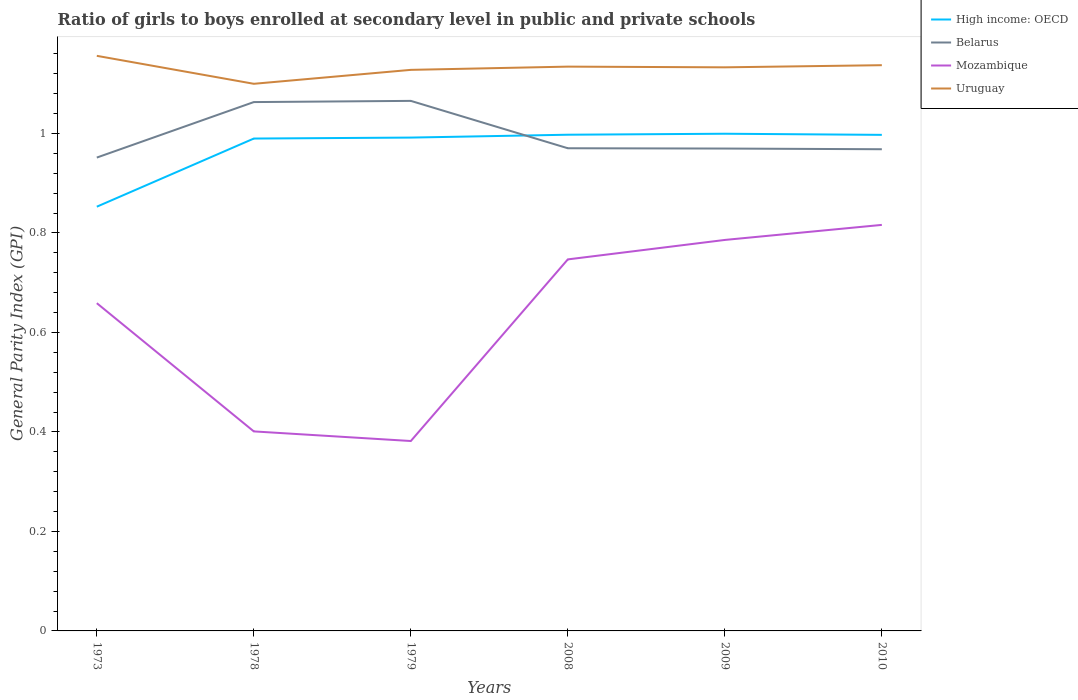Does the line corresponding to Mozambique intersect with the line corresponding to High income: OECD?
Your response must be concise. No. Is the number of lines equal to the number of legend labels?
Keep it short and to the point. Yes. Across all years, what is the maximum general parity index in Uruguay?
Ensure brevity in your answer.  1.1. What is the total general parity index in High income: OECD in the graph?
Your answer should be very brief. -0.01. What is the difference between the highest and the second highest general parity index in Belarus?
Provide a succinct answer. 0.11. What is the difference between the highest and the lowest general parity index in High income: OECD?
Make the answer very short. 5. Does the graph contain any zero values?
Provide a short and direct response. No. Where does the legend appear in the graph?
Keep it short and to the point. Top right. How many legend labels are there?
Your answer should be very brief. 4. What is the title of the graph?
Provide a succinct answer. Ratio of girls to boys enrolled at secondary level in public and private schools. What is the label or title of the Y-axis?
Provide a short and direct response. General Parity Index (GPI). What is the General Parity Index (GPI) of High income: OECD in 1973?
Give a very brief answer. 0.85. What is the General Parity Index (GPI) in Belarus in 1973?
Provide a succinct answer. 0.95. What is the General Parity Index (GPI) of Mozambique in 1973?
Offer a terse response. 0.66. What is the General Parity Index (GPI) in Uruguay in 1973?
Give a very brief answer. 1.16. What is the General Parity Index (GPI) in High income: OECD in 1978?
Provide a short and direct response. 0.99. What is the General Parity Index (GPI) in Belarus in 1978?
Give a very brief answer. 1.06. What is the General Parity Index (GPI) in Mozambique in 1978?
Offer a terse response. 0.4. What is the General Parity Index (GPI) in Uruguay in 1978?
Your answer should be compact. 1.1. What is the General Parity Index (GPI) of High income: OECD in 1979?
Give a very brief answer. 0.99. What is the General Parity Index (GPI) in Belarus in 1979?
Make the answer very short. 1.07. What is the General Parity Index (GPI) of Mozambique in 1979?
Your answer should be compact. 0.38. What is the General Parity Index (GPI) in Uruguay in 1979?
Your response must be concise. 1.13. What is the General Parity Index (GPI) of High income: OECD in 2008?
Your answer should be compact. 1. What is the General Parity Index (GPI) in Belarus in 2008?
Ensure brevity in your answer.  0.97. What is the General Parity Index (GPI) of Mozambique in 2008?
Keep it short and to the point. 0.75. What is the General Parity Index (GPI) of Uruguay in 2008?
Ensure brevity in your answer.  1.13. What is the General Parity Index (GPI) of High income: OECD in 2009?
Offer a very short reply. 1. What is the General Parity Index (GPI) in Belarus in 2009?
Provide a succinct answer. 0.97. What is the General Parity Index (GPI) of Mozambique in 2009?
Your answer should be compact. 0.79. What is the General Parity Index (GPI) of Uruguay in 2009?
Offer a terse response. 1.13. What is the General Parity Index (GPI) of High income: OECD in 2010?
Make the answer very short. 1. What is the General Parity Index (GPI) in Belarus in 2010?
Offer a very short reply. 0.97. What is the General Parity Index (GPI) in Mozambique in 2010?
Provide a succinct answer. 0.82. What is the General Parity Index (GPI) of Uruguay in 2010?
Ensure brevity in your answer.  1.14. Across all years, what is the maximum General Parity Index (GPI) of High income: OECD?
Provide a succinct answer. 1. Across all years, what is the maximum General Parity Index (GPI) of Belarus?
Ensure brevity in your answer.  1.07. Across all years, what is the maximum General Parity Index (GPI) in Mozambique?
Offer a very short reply. 0.82. Across all years, what is the maximum General Parity Index (GPI) in Uruguay?
Offer a terse response. 1.16. Across all years, what is the minimum General Parity Index (GPI) in High income: OECD?
Give a very brief answer. 0.85. Across all years, what is the minimum General Parity Index (GPI) of Belarus?
Provide a succinct answer. 0.95. Across all years, what is the minimum General Parity Index (GPI) of Mozambique?
Your answer should be compact. 0.38. Across all years, what is the minimum General Parity Index (GPI) in Uruguay?
Ensure brevity in your answer.  1.1. What is the total General Parity Index (GPI) in High income: OECD in the graph?
Offer a very short reply. 5.83. What is the total General Parity Index (GPI) in Belarus in the graph?
Provide a short and direct response. 5.99. What is the total General Parity Index (GPI) in Mozambique in the graph?
Your answer should be very brief. 3.79. What is the total General Parity Index (GPI) of Uruguay in the graph?
Offer a terse response. 6.79. What is the difference between the General Parity Index (GPI) of High income: OECD in 1973 and that in 1978?
Provide a succinct answer. -0.14. What is the difference between the General Parity Index (GPI) in Belarus in 1973 and that in 1978?
Your answer should be compact. -0.11. What is the difference between the General Parity Index (GPI) in Mozambique in 1973 and that in 1978?
Give a very brief answer. 0.26. What is the difference between the General Parity Index (GPI) of Uruguay in 1973 and that in 1978?
Provide a succinct answer. 0.06. What is the difference between the General Parity Index (GPI) in High income: OECD in 1973 and that in 1979?
Your answer should be compact. -0.14. What is the difference between the General Parity Index (GPI) of Belarus in 1973 and that in 1979?
Your response must be concise. -0.11. What is the difference between the General Parity Index (GPI) in Mozambique in 1973 and that in 1979?
Make the answer very short. 0.28. What is the difference between the General Parity Index (GPI) in Uruguay in 1973 and that in 1979?
Make the answer very short. 0.03. What is the difference between the General Parity Index (GPI) in High income: OECD in 1973 and that in 2008?
Provide a short and direct response. -0.14. What is the difference between the General Parity Index (GPI) of Belarus in 1973 and that in 2008?
Offer a very short reply. -0.02. What is the difference between the General Parity Index (GPI) of Mozambique in 1973 and that in 2008?
Offer a terse response. -0.09. What is the difference between the General Parity Index (GPI) of Uruguay in 1973 and that in 2008?
Your answer should be very brief. 0.02. What is the difference between the General Parity Index (GPI) of High income: OECD in 1973 and that in 2009?
Provide a short and direct response. -0.15. What is the difference between the General Parity Index (GPI) of Belarus in 1973 and that in 2009?
Give a very brief answer. -0.02. What is the difference between the General Parity Index (GPI) in Mozambique in 1973 and that in 2009?
Keep it short and to the point. -0.13. What is the difference between the General Parity Index (GPI) of Uruguay in 1973 and that in 2009?
Provide a short and direct response. 0.02. What is the difference between the General Parity Index (GPI) in High income: OECD in 1973 and that in 2010?
Give a very brief answer. -0.14. What is the difference between the General Parity Index (GPI) of Belarus in 1973 and that in 2010?
Your answer should be compact. -0.02. What is the difference between the General Parity Index (GPI) of Mozambique in 1973 and that in 2010?
Offer a very short reply. -0.16. What is the difference between the General Parity Index (GPI) in Uruguay in 1973 and that in 2010?
Your answer should be very brief. 0.02. What is the difference between the General Parity Index (GPI) of High income: OECD in 1978 and that in 1979?
Offer a terse response. -0. What is the difference between the General Parity Index (GPI) of Belarus in 1978 and that in 1979?
Make the answer very short. -0. What is the difference between the General Parity Index (GPI) of Mozambique in 1978 and that in 1979?
Your answer should be compact. 0.02. What is the difference between the General Parity Index (GPI) of Uruguay in 1978 and that in 1979?
Your answer should be very brief. -0.03. What is the difference between the General Parity Index (GPI) in High income: OECD in 1978 and that in 2008?
Provide a short and direct response. -0.01. What is the difference between the General Parity Index (GPI) in Belarus in 1978 and that in 2008?
Your response must be concise. 0.09. What is the difference between the General Parity Index (GPI) of Mozambique in 1978 and that in 2008?
Give a very brief answer. -0.35. What is the difference between the General Parity Index (GPI) in Uruguay in 1978 and that in 2008?
Your answer should be very brief. -0.03. What is the difference between the General Parity Index (GPI) in High income: OECD in 1978 and that in 2009?
Your response must be concise. -0.01. What is the difference between the General Parity Index (GPI) of Belarus in 1978 and that in 2009?
Offer a very short reply. 0.09. What is the difference between the General Parity Index (GPI) of Mozambique in 1978 and that in 2009?
Offer a very short reply. -0.38. What is the difference between the General Parity Index (GPI) of Uruguay in 1978 and that in 2009?
Provide a short and direct response. -0.03. What is the difference between the General Parity Index (GPI) of High income: OECD in 1978 and that in 2010?
Make the answer very short. -0.01. What is the difference between the General Parity Index (GPI) of Belarus in 1978 and that in 2010?
Provide a short and direct response. 0.09. What is the difference between the General Parity Index (GPI) of Mozambique in 1978 and that in 2010?
Offer a terse response. -0.42. What is the difference between the General Parity Index (GPI) of Uruguay in 1978 and that in 2010?
Make the answer very short. -0.04. What is the difference between the General Parity Index (GPI) in High income: OECD in 1979 and that in 2008?
Ensure brevity in your answer.  -0.01. What is the difference between the General Parity Index (GPI) of Belarus in 1979 and that in 2008?
Offer a terse response. 0.1. What is the difference between the General Parity Index (GPI) of Mozambique in 1979 and that in 2008?
Offer a terse response. -0.37. What is the difference between the General Parity Index (GPI) in Uruguay in 1979 and that in 2008?
Offer a very short reply. -0.01. What is the difference between the General Parity Index (GPI) of High income: OECD in 1979 and that in 2009?
Your answer should be very brief. -0.01. What is the difference between the General Parity Index (GPI) in Belarus in 1979 and that in 2009?
Your answer should be compact. 0.1. What is the difference between the General Parity Index (GPI) of Mozambique in 1979 and that in 2009?
Ensure brevity in your answer.  -0.4. What is the difference between the General Parity Index (GPI) in Uruguay in 1979 and that in 2009?
Offer a terse response. -0.01. What is the difference between the General Parity Index (GPI) of High income: OECD in 1979 and that in 2010?
Keep it short and to the point. -0.01. What is the difference between the General Parity Index (GPI) in Belarus in 1979 and that in 2010?
Offer a very short reply. 0.1. What is the difference between the General Parity Index (GPI) of Mozambique in 1979 and that in 2010?
Keep it short and to the point. -0.43. What is the difference between the General Parity Index (GPI) of Uruguay in 1979 and that in 2010?
Offer a terse response. -0.01. What is the difference between the General Parity Index (GPI) in High income: OECD in 2008 and that in 2009?
Offer a terse response. -0. What is the difference between the General Parity Index (GPI) of Belarus in 2008 and that in 2009?
Provide a succinct answer. 0. What is the difference between the General Parity Index (GPI) in Mozambique in 2008 and that in 2009?
Ensure brevity in your answer.  -0.04. What is the difference between the General Parity Index (GPI) in Uruguay in 2008 and that in 2009?
Provide a succinct answer. 0. What is the difference between the General Parity Index (GPI) of Belarus in 2008 and that in 2010?
Your response must be concise. 0. What is the difference between the General Parity Index (GPI) of Mozambique in 2008 and that in 2010?
Offer a very short reply. -0.07. What is the difference between the General Parity Index (GPI) in Uruguay in 2008 and that in 2010?
Make the answer very short. -0. What is the difference between the General Parity Index (GPI) of High income: OECD in 2009 and that in 2010?
Keep it short and to the point. 0. What is the difference between the General Parity Index (GPI) of Belarus in 2009 and that in 2010?
Make the answer very short. 0. What is the difference between the General Parity Index (GPI) of Mozambique in 2009 and that in 2010?
Your response must be concise. -0.03. What is the difference between the General Parity Index (GPI) in Uruguay in 2009 and that in 2010?
Offer a terse response. -0. What is the difference between the General Parity Index (GPI) in High income: OECD in 1973 and the General Parity Index (GPI) in Belarus in 1978?
Keep it short and to the point. -0.21. What is the difference between the General Parity Index (GPI) of High income: OECD in 1973 and the General Parity Index (GPI) of Mozambique in 1978?
Your response must be concise. 0.45. What is the difference between the General Parity Index (GPI) in High income: OECD in 1973 and the General Parity Index (GPI) in Uruguay in 1978?
Your response must be concise. -0.25. What is the difference between the General Parity Index (GPI) of Belarus in 1973 and the General Parity Index (GPI) of Mozambique in 1978?
Make the answer very short. 0.55. What is the difference between the General Parity Index (GPI) in Belarus in 1973 and the General Parity Index (GPI) in Uruguay in 1978?
Provide a short and direct response. -0.15. What is the difference between the General Parity Index (GPI) in Mozambique in 1973 and the General Parity Index (GPI) in Uruguay in 1978?
Your answer should be compact. -0.44. What is the difference between the General Parity Index (GPI) in High income: OECD in 1973 and the General Parity Index (GPI) in Belarus in 1979?
Provide a short and direct response. -0.21. What is the difference between the General Parity Index (GPI) of High income: OECD in 1973 and the General Parity Index (GPI) of Mozambique in 1979?
Make the answer very short. 0.47. What is the difference between the General Parity Index (GPI) of High income: OECD in 1973 and the General Parity Index (GPI) of Uruguay in 1979?
Offer a very short reply. -0.28. What is the difference between the General Parity Index (GPI) in Belarus in 1973 and the General Parity Index (GPI) in Mozambique in 1979?
Your response must be concise. 0.57. What is the difference between the General Parity Index (GPI) of Belarus in 1973 and the General Parity Index (GPI) of Uruguay in 1979?
Your answer should be compact. -0.18. What is the difference between the General Parity Index (GPI) in Mozambique in 1973 and the General Parity Index (GPI) in Uruguay in 1979?
Provide a short and direct response. -0.47. What is the difference between the General Parity Index (GPI) of High income: OECD in 1973 and the General Parity Index (GPI) of Belarus in 2008?
Keep it short and to the point. -0.12. What is the difference between the General Parity Index (GPI) in High income: OECD in 1973 and the General Parity Index (GPI) in Mozambique in 2008?
Your answer should be very brief. 0.11. What is the difference between the General Parity Index (GPI) of High income: OECD in 1973 and the General Parity Index (GPI) of Uruguay in 2008?
Ensure brevity in your answer.  -0.28. What is the difference between the General Parity Index (GPI) in Belarus in 1973 and the General Parity Index (GPI) in Mozambique in 2008?
Ensure brevity in your answer.  0.2. What is the difference between the General Parity Index (GPI) of Belarus in 1973 and the General Parity Index (GPI) of Uruguay in 2008?
Your answer should be very brief. -0.18. What is the difference between the General Parity Index (GPI) in Mozambique in 1973 and the General Parity Index (GPI) in Uruguay in 2008?
Give a very brief answer. -0.48. What is the difference between the General Parity Index (GPI) in High income: OECD in 1973 and the General Parity Index (GPI) in Belarus in 2009?
Your answer should be compact. -0.12. What is the difference between the General Parity Index (GPI) in High income: OECD in 1973 and the General Parity Index (GPI) in Mozambique in 2009?
Offer a very short reply. 0.07. What is the difference between the General Parity Index (GPI) in High income: OECD in 1973 and the General Parity Index (GPI) in Uruguay in 2009?
Offer a terse response. -0.28. What is the difference between the General Parity Index (GPI) of Belarus in 1973 and the General Parity Index (GPI) of Mozambique in 2009?
Your answer should be compact. 0.17. What is the difference between the General Parity Index (GPI) in Belarus in 1973 and the General Parity Index (GPI) in Uruguay in 2009?
Your response must be concise. -0.18. What is the difference between the General Parity Index (GPI) in Mozambique in 1973 and the General Parity Index (GPI) in Uruguay in 2009?
Keep it short and to the point. -0.47. What is the difference between the General Parity Index (GPI) of High income: OECD in 1973 and the General Parity Index (GPI) of Belarus in 2010?
Ensure brevity in your answer.  -0.12. What is the difference between the General Parity Index (GPI) in High income: OECD in 1973 and the General Parity Index (GPI) in Mozambique in 2010?
Ensure brevity in your answer.  0.04. What is the difference between the General Parity Index (GPI) of High income: OECD in 1973 and the General Parity Index (GPI) of Uruguay in 2010?
Ensure brevity in your answer.  -0.28. What is the difference between the General Parity Index (GPI) of Belarus in 1973 and the General Parity Index (GPI) of Mozambique in 2010?
Provide a short and direct response. 0.14. What is the difference between the General Parity Index (GPI) in Belarus in 1973 and the General Parity Index (GPI) in Uruguay in 2010?
Your answer should be compact. -0.19. What is the difference between the General Parity Index (GPI) of Mozambique in 1973 and the General Parity Index (GPI) of Uruguay in 2010?
Ensure brevity in your answer.  -0.48. What is the difference between the General Parity Index (GPI) in High income: OECD in 1978 and the General Parity Index (GPI) in Belarus in 1979?
Provide a short and direct response. -0.08. What is the difference between the General Parity Index (GPI) of High income: OECD in 1978 and the General Parity Index (GPI) of Mozambique in 1979?
Keep it short and to the point. 0.61. What is the difference between the General Parity Index (GPI) of High income: OECD in 1978 and the General Parity Index (GPI) of Uruguay in 1979?
Offer a very short reply. -0.14. What is the difference between the General Parity Index (GPI) of Belarus in 1978 and the General Parity Index (GPI) of Mozambique in 1979?
Give a very brief answer. 0.68. What is the difference between the General Parity Index (GPI) of Belarus in 1978 and the General Parity Index (GPI) of Uruguay in 1979?
Provide a short and direct response. -0.06. What is the difference between the General Parity Index (GPI) of Mozambique in 1978 and the General Parity Index (GPI) of Uruguay in 1979?
Your answer should be compact. -0.73. What is the difference between the General Parity Index (GPI) in High income: OECD in 1978 and the General Parity Index (GPI) in Belarus in 2008?
Provide a short and direct response. 0.02. What is the difference between the General Parity Index (GPI) in High income: OECD in 1978 and the General Parity Index (GPI) in Mozambique in 2008?
Give a very brief answer. 0.24. What is the difference between the General Parity Index (GPI) of High income: OECD in 1978 and the General Parity Index (GPI) of Uruguay in 2008?
Offer a terse response. -0.14. What is the difference between the General Parity Index (GPI) in Belarus in 1978 and the General Parity Index (GPI) in Mozambique in 2008?
Give a very brief answer. 0.32. What is the difference between the General Parity Index (GPI) in Belarus in 1978 and the General Parity Index (GPI) in Uruguay in 2008?
Provide a short and direct response. -0.07. What is the difference between the General Parity Index (GPI) of Mozambique in 1978 and the General Parity Index (GPI) of Uruguay in 2008?
Give a very brief answer. -0.73. What is the difference between the General Parity Index (GPI) in High income: OECD in 1978 and the General Parity Index (GPI) in Belarus in 2009?
Your answer should be compact. 0.02. What is the difference between the General Parity Index (GPI) of High income: OECD in 1978 and the General Parity Index (GPI) of Mozambique in 2009?
Provide a succinct answer. 0.2. What is the difference between the General Parity Index (GPI) of High income: OECD in 1978 and the General Parity Index (GPI) of Uruguay in 2009?
Ensure brevity in your answer.  -0.14. What is the difference between the General Parity Index (GPI) of Belarus in 1978 and the General Parity Index (GPI) of Mozambique in 2009?
Make the answer very short. 0.28. What is the difference between the General Parity Index (GPI) of Belarus in 1978 and the General Parity Index (GPI) of Uruguay in 2009?
Your answer should be compact. -0.07. What is the difference between the General Parity Index (GPI) in Mozambique in 1978 and the General Parity Index (GPI) in Uruguay in 2009?
Ensure brevity in your answer.  -0.73. What is the difference between the General Parity Index (GPI) in High income: OECD in 1978 and the General Parity Index (GPI) in Belarus in 2010?
Your answer should be very brief. 0.02. What is the difference between the General Parity Index (GPI) in High income: OECD in 1978 and the General Parity Index (GPI) in Mozambique in 2010?
Your answer should be compact. 0.17. What is the difference between the General Parity Index (GPI) of High income: OECD in 1978 and the General Parity Index (GPI) of Uruguay in 2010?
Offer a terse response. -0.15. What is the difference between the General Parity Index (GPI) of Belarus in 1978 and the General Parity Index (GPI) of Mozambique in 2010?
Your answer should be very brief. 0.25. What is the difference between the General Parity Index (GPI) of Belarus in 1978 and the General Parity Index (GPI) of Uruguay in 2010?
Offer a terse response. -0.07. What is the difference between the General Parity Index (GPI) of Mozambique in 1978 and the General Parity Index (GPI) of Uruguay in 2010?
Offer a terse response. -0.74. What is the difference between the General Parity Index (GPI) of High income: OECD in 1979 and the General Parity Index (GPI) of Belarus in 2008?
Ensure brevity in your answer.  0.02. What is the difference between the General Parity Index (GPI) of High income: OECD in 1979 and the General Parity Index (GPI) of Mozambique in 2008?
Provide a short and direct response. 0.24. What is the difference between the General Parity Index (GPI) in High income: OECD in 1979 and the General Parity Index (GPI) in Uruguay in 2008?
Give a very brief answer. -0.14. What is the difference between the General Parity Index (GPI) of Belarus in 1979 and the General Parity Index (GPI) of Mozambique in 2008?
Offer a very short reply. 0.32. What is the difference between the General Parity Index (GPI) in Belarus in 1979 and the General Parity Index (GPI) in Uruguay in 2008?
Keep it short and to the point. -0.07. What is the difference between the General Parity Index (GPI) in Mozambique in 1979 and the General Parity Index (GPI) in Uruguay in 2008?
Offer a terse response. -0.75. What is the difference between the General Parity Index (GPI) in High income: OECD in 1979 and the General Parity Index (GPI) in Belarus in 2009?
Your response must be concise. 0.02. What is the difference between the General Parity Index (GPI) of High income: OECD in 1979 and the General Parity Index (GPI) of Mozambique in 2009?
Provide a short and direct response. 0.21. What is the difference between the General Parity Index (GPI) in High income: OECD in 1979 and the General Parity Index (GPI) in Uruguay in 2009?
Offer a very short reply. -0.14. What is the difference between the General Parity Index (GPI) of Belarus in 1979 and the General Parity Index (GPI) of Mozambique in 2009?
Keep it short and to the point. 0.28. What is the difference between the General Parity Index (GPI) of Belarus in 1979 and the General Parity Index (GPI) of Uruguay in 2009?
Your answer should be very brief. -0.07. What is the difference between the General Parity Index (GPI) of Mozambique in 1979 and the General Parity Index (GPI) of Uruguay in 2009?
Make the answer very short. -0.75. What is the difference between the General Parity Index (GPI) of High income: OECD in 1979 and the General Parity Index (GPI) of Belarus in 2010?
Your response must be concise. 0.02. What is the difference between the General Parity Index (GPI) in High income: OECD in 1979 and the General Parity Index (GPI) in Mozambique in 2010?
Ensure brevity in your answer.  0.18. What is the difference between the General Parity Index (GPI) in High income: OECD in 1979 and the General Parity Index (GPI) in Uruguay in 2010?
Your answer should be very brief. -0.15. What is the difference between the General Parity Index (GPI) in Belarus in 1979 and the General Parity Index (GPI) in Mozambique in 2010?
Offer a very short reply. 0.25. What is the difference between the General Parity Index (GPI) of Belarus in 1979 and the General Parity Index (GPI) of Uruguay in 2010?
Your answer should be very brief. -0.07. What is the difference between the General Parity Index (GPI) in Mozambique in 1979 and the General Parity Index (GPI) in Uruguay in 2010?
Offer a terse response. -0.76. What is the difference between the General Parity Index (GPI) of High income: OECD in 2008 and the General Parity Index (GPI) of Belarus in 2009?
Provide a succinct answer. 0.03. What is the difference between the General Parity Index (GPI) of High income: OECD in 2008 and the General Parity Index (GPI) of Mozambique in 2009?
Offer a very short reply. 0.21. What is the difference between the General Parity Index (GPI) of High income: OECD in 2008 and the General Parity Index (GPI) of Uruguay in 2009?
Your answer should be very brief. -0.14. What is the difference between the General Parity Index (GPI) of Belarus in 2008 and the General Parity Index (GPI) of Mozambique in 2009?
Ensure brevity in your answer.  0.18. What is the difference between the General Parity Index (GPI) in Belarus in 2008 and the General Parity Index (GPI) in Uruguay in 2009?
Offer a very short reply. -0.16. What is the difference between the General Parity Index (GPI) in Mozambique in 2008 and the General Parity Index (GPI) in Uruguay in 2009?
Give a very brief answer. -0.39. What is the difference between the General Parity Index (GPI) in High income: OECD in 2008 and the General Parity Index (GPI) in Belarus in 2010?
Offer a very short reply. 0.03. What is the difference between the General Parity Index (GPI) of High income: OECD in 2008 and the General Parity Index (GPI) of Mozambique in 2010?
Your answer should be compact. 0.18. What is the difference between the General Parity Index (GPI) of High income: OECD in 2008 and the General Parity Index (GPI) of Uruguay in 2010?
Your answer should be compact. -0.14. What is the difference between the General Parity Index (GPI) of Belarus in 2008 and the General Parity Index (GPI) of Mozambique in 2010?
Ensure brevity in your answer.  0.15. What is the difference between the General Parity Index (GPI) in Belarus in 2008 and the General Parity Index (GPI) in Uruguay in 2010?
Your answer should be very brief. -0.17. What is the difference between the General Parity Index (GPI) of Mozambique in 2008 and the General Parity Index (GPI) of Uruguay in 2010?
Make the answer very short. -0.39. What is the difference between the General Parity Index (GPI) of High income: OECD in 2009 and the General Parity Index (GPI) of Belarus in 2010?
Your response must be concise. 0.03. What is the difference between the General Parity Index (GPI) of High income: OECD in 2009 and the General Parity Index (GPI) of Mozambique in 2010?
Offer a terse response. 0.18. What is the difference between the General Parity Index (GPI) of High income: OECD in 2009 and the General Parity Index (GPI) of Uruguay in 2010?
Your answer should be very brief. -0.14. What is the difference between the General Parity Index (GPI) of Belarus in 2009 and the General Parity Index (GPI) of Mozambique in 2010?
Provide a short and direct response. 0.15. What is the difference between the General Parity Index (GPI) of Belarus in 2009 and the General Parity Index (GPI) of Uruguay in 2010?
Your response must be concise. -0.17. What is the difference between the General Parity Index (GPI) of Mozambique in 2009 and the General Parity Index (GPI) of Uruguay in 2010?
Keep it short and to the point. -0.35. What is the average General Parity Index (GPI) of High income: OECD per year?
Make the answer very short. 0.97. What is the average General Parity Index (GPI) in Belarus per year?
Your response must be concise. 1. What is the average General Parity Index (GPI) in Mozambique per year?
Ensure brevity in your answer.  0.63. What is the average General Parity Index (GPI) in Uruguay per year?
Make the answer very short. 1.13. In the year 1973, what is the difference between the General Parity Index (GPI) of High income: OECD and General Parity Index (GPI) of Belarus?
Your answer should be very brief. -0.1. In the year 1973, what is the difference between the General Parity Index (GPI) of High income: OECD and General Parity Index (GPI) of Mozambique?
Make the answer very short. 0.19. In the year 1973, what is the difference between the General Parity Index (GPI) of High income: OECD and General Parity Index (GPI) of Uruguay?
Keep it short and to the point. -0.3. In the year 1973, what is the difference between the General Parity Index (GPI) in Belarus and General Parity Index (GPI) in Mozambique?
Ensure brevity in your answer.  0.29. In the year 1973, what is the difference between the General Parity Index (GPI) of Belarus and General Parity Index (GPI) of Uruguay?
Provide a short and direct response. -0.2. In the year 1973, what is the difference between the General Parity Index (GPI) of Mozambique and General Parity Index (GPI) of Uruguay?
Offer a very short reply. -0.5. In the year 1978, what is the difference between the General Parity Index (GPI) of High income: OECD and General Parity Index (GPI) of Belarus?
Your answer should be compact. -0.07. In the year 1978, what is the difference between the General Parity Index (GPI) of High income: OECD and General Parity Index (GPI) of Mozambique?
Your answer should be very brief. 0.59. In the year 1978, what is the difference between the General Parity Index (GPI) of High income: OECD and General Parity Index (GPI) of Uruguay?
Provide a short and direct response. -0.11. In the year 1978, what is the difference between the General Parity Index (GPI) in Belarus and General Parity Index (GPI) in Mozambique?
Ensure brevity in your answer.  0.66. In the year 1978, what is the difference between the General Parity Index (GPI) of Belarus and General Parity Index (GPI) of Uruguay?
Provide a short and direct response. -0.04. In the year 1978, what is the difference between the General Parity Index (GPI) in Mozambique and General Parity Index (GPI) in Uruguay?
Make the answer very short. -0.7. In the year 1979, what is the difference between the General Parity Index (GPI) of High income: OECD and General Parity Index (GPI) of Belarus?
Your answer should be very brief. -0.07. In the year 1979, what is the difference between the General Parity Index (GPI) in High income: OECD and General Parity Index (GPI) in Mozambique?
Offer a very short reply. 0.61. In the year 1979, what is the difference between the General Parity Index (GPI) in High income: OECD and General Parity Index (GPI) in Uruguay?
Provide a succinct answer. -0.14. In the year 1979, what is the difference between the General Parity Index (GPI) of Belarus and General Parity Index (GPI) of Mozambique?
Offer a very short reply. 0.68. In the year 1979, what is the difference between the General Parity Index (GPI) in Belarus and General Parity Index (GPI) in Uruguay?
Make the answer very short. -0.06. In the year 1979, what is the difference between the General Parity Index (GPI) in Mozambique and General Parity Index (GPI) in Uruguay?
Your answer should be compact. -0.75. In the year 2008, what is the difference between the General Parity Index (GPI) in High income: OECD and General Parity Index (GPI) in Belarus?
Provide a succinct answer. 0.03. In the year 2008, what is the difference between the General Parity Index (GPI) in High income: OECD and General Parity Index (GPI) in Mozambique?
Your answer should be compact. 0.25. In the year 2008, what is the difference between the General Parity Index (GPI) in High income: OECD and General Parity Index (GPI) in Uruguay?
Offer a terse response. -0.14. In the year 2008, what is the difference between the General Parity Index (GPI) of Belarus and General Parity Index (GPI) of Mozambique?
Offer a terse response. 0.22. In the year 2008, what is the difference between the General Parity Index (GPI) of Belarus and General Parity Index (GPI) of Uruguay?
Offer a very short reply. -0.16. In the year 2008, what is the difference between the General Parity Index (GPI) of Mozambique and General Parity Index (GPI) of Uruguay?
Your answer should be very brief. -0.39. In the year 2009, what is the difference between the General Parity Index (GPI) of High income: OECD and General Parity Index (GPI) of Belarus?
Make the answer very short. 0.03. In the year 2009, what is the difference between the General Parity Index (GPI) in High income: OECD and General Parity Index (GPI) in Mozambique?
Provide a succinct answer. 0.21. In the year 2009, what is the difference between the General Parity Index (GPI) in High income: OECD and General Parity Index (GPI) in Uruguay?
Your answer should be very brief. -0.13. In the year 2009, what is the difference between the General Parity Index (GPI) of Belarus and General Parity Index (GPI) of Mozambique?
Keep it short and to the point. 0.18. In the year 2009, what is the difference between the General Parity Index (GPI) in Belarus and General Parity Index (GPI) in Uruguay?
Offer a very short reply. -0.16. In the year 2009, what is the difference between the General Parity Index (GPI) in Mozambique and General Parity Index (GPI) in Uruguay?
Offer a very short reply. -0.35. In the year 2010, what is the difference between the General Parity Index (GPI) in High income: OECD and General Parity Index (GPI) in Belarus?
Provide a succinct answer. 0.03. In the year 2010, what is the difference between the General Parity Index (GPI) in High income: OECD and General Parity Index (GPI) in Mozambique?
Provide a succinct answer. 0.18. In the year 2010, what is the difference between the General Parity Index (GPI) of High income: OECD and General Parity Index (GPI) of Uruguay?
Offer a terse response. -0.14. In the year 2010, what is the difference between the General Parity Index (GPI) in Belarus and General Parity Index (GPI) in Mozambique?
Keep it short and to the point. 0.15. In the year 2010, what is the difference between the General Parity Index (GPI) in Belarus and General Parity Index (GPI) in Uruguay?
Keep it short and to the point. -0.17. In the year 2010, what is the difference between the General Parity Index (GPI) in Mozambique and General Parity Index (GPI) in Uruguay?
Keep it short and to the point. -0.32. What is the ratio of the General Parity Index (GPI) of High income: OECD in 1973 to that in 1978?
Provide a short and direct response. 0.86. What is the ratio of the General Parity Index (GPI) in Belarus in 1973 to that in 1978?
Offer a very short reply. 0.9. What is the ratio of the General Parity Index (GPI) of Mozambique in 1973 to that in 1978?
Provide a short and direct response. 1.64. What is the ratio of the General Parity Index (GPI) of Uruguay in 1973 to that in 1978?
Your answer should be compact. 1.05. What is the ratio of the General Parity Index (GPI) of High income: OECD in 1973 to that in 1979?
Make the answer very short. 0.86. What is the ratio of the General Parity Index (GPI) in Belarus in 1973 to that in 1979?
Provide a succinct answer. 0.89. What is the ratio of the General Parity Index (GPI) of Mozambique in 1973 to that in 1979?
Your response must be concise. 1.73. What is the ratio of the General Parity Index (GPI) in High income: OECD in 1973 to that in 2008?
Make the answer very short. 0.85. What is the ratio of the General Parity Index (GPI) in Belarus in 1973 to that in 2008?
Offer a terse response. 0.98. What is the ratio of the General Parity Index (GPI) in Mozambique in 1973 to that in 2008?
Your answer should be compact. 0.88. What is the ratio of the General Parity Index (GPI) of Uruguay in 1973 to that in 2008?
Provide a short and direct response. 1.02. What is the ratio of the General Parity Index (GPI) of High income: OECD in 1973 to that in 2009?
Ensure brevity in your answer.  0.85. What is the ratio of the General Parity Index (GPI) in Belarus in 1973 to that in 2009?
Provide a short and direct response. 0.98. What is the ratio of the General Parity Index (GPI) of Mozambique in 1973 to that in 2009?
Offer a very short reply. 0.84. What is the ratio of the General Parity Index (GPI) of Uruguay in 1973 to that in 2009?
Give a very brief answer. 1.02. What is the ratio of the General Parity Index (GPI) of High income: OECD in 1973 to that in 2010?
Provide a short and direct response. 0.86. What is the ratio of the General Parity Index (GPI) in Belarus in 1973 to that in 2010?
Give a very brief answer. 0.98. What is the ratio of the General Parity Index (GPI) of Mozambique in 1973 to that in 2010?
Ensure brevity in your answer.  0.81. What is the ratio of the General Parity Index (GPI) in Uruguay in 1973 to that in 2010?
Provide a short and direct response. 1.02. What is the ratio of the General Parity Index (GPI) in High income: OECD in 1978 to that in 1979?
Your answer should be very brief. 1. What is the ratio of the General Parity Index (GPI) of Belarus in 1978 to that in 1979?
Make the answer very short. 1. What is the ratio of the General Parity Index (GPI) of Mozambique in 1978 to that in 1979?
Provide a succinct answer. 1.05. What is the ratio of the General Parity Index (GPI) in Uruguay in 1978 to that in 1979?
Give a very brief answer. 0.98. What is the ratio of the General Parity Index (GPI) of Belarus in 1978 to that in 2008?
Ensure brevity in your answer.  1.1. What is the ratio of the General Parity Index (GPI) in Mozambique in 1978 to that in 2008?
Offer a very short reply. 0.54. What is the ratio of the General Parity Index (GPI) of Uruguay in 1978 to that in 2008?
Keep it short and to the point. 0.97. What is the ratio of the General Parity Index (GPI) of High income: OECD in 1978 to that in 2009?
Offer a very short reply. 0.99. What is the ratio of the General Parity Index (GPI) of Belarus in 1978 to that in 2009?
Your answer should be compact. 1.1. What is the ratio of the General Parity Index (GPI) of Mozambique in 1978 to that in 2009?
Keep it short and to the point. 0.51. What is the ratio of the General Parity Index (GPI) in Uruguay in 1978 to that in 2009?
Your answer should be very brief. 0.97. What is the ratio of the General Parity Index (GPI) in Belarus in 1978 to that in 2010?
Your answer should be very brief. 1.1. What is the ratio of the General Parity Index (GPI) of Mozambique in 1978 to that in 2010?
Make the answer very short. 0.49. What is the ratio of the General Parity Index (GPI) in Uruguay in 1978 to that in 2010?
Give a very brief answer. 0.97. What is the ratio of the General Parity Index (GPI) of High income: OECD in 1979 to that in 2008?
Your answer should be compact. 0.99. What is the ratio of the General Parity Index (GPI) in Belarus in 1979 to that in 2008?
Keep it short and to the point. 1.1. What is the ratio of the General Parity Index (GPI) of Mozambique in 1979 to that in 2008?
Ensure brevity in your answer.  0.51. What is the ratio of the General Parity Index (GPI) of Belarus in 1979 to that in 2009?
Your response must be concise. 1.1. What is the ratio of the General Parity Index (GPI) in Mozambique in 1979 to that in 2009?
Offer a very short reply. 0.49. What is the ratio of the General Parity Index (GPI) in Uruguay in 1979 to that in 2009?
Give a very brief answer. 1. What is the ratio of the General Parity Index (GPI) of Belarus in 1979 to that in 2010?
Keep it short and to the point. 1.1. What is the ratio of the General Parity Index (GPI) of Mozambique in 1979 to that in 2010?
Offer a very short reply. 0.47. What is the ratio of the General Parity Index (GPI) of High income: OECD in 2008 to that in 2009?
Give a very brief answer. 1. What is the ratio of the General Parity Index (GPI) of Belarus in 2008 to that in 2009?
Offer a very short reply. 1. What is the ratio of the General Parity Index (GPI) in Mozambique in 2008 to that in 2009?
Your answer should be compact. 0.95. What is the ratio of the General Parity Index (GPI) of Belarus in 2008 to that in 2010?
Provide a succinct answer. 1. What is the ratio of the General Parity Index (GPI) in Mozambique in 2008 to that in 2010?
Give a very brief answer. 0.92. What is the ratio of the General Parity Index (GPI) in Uruguay in 2008 to that in 2010?
Your answer should be compact. 1. What is the ratio of the General Parity Index (GPI) of High income: OECD in 2009 to that in 2010?
Provide a short and direct response. 1. What is the ratio of the General Parity Index (GPI) in Belarus in 2009 to that in 2010?
Offer a very short reply. 1. What is the ratio of the General Parity Index (GPI) of Mozambique in 2009 to that in 2010?
Provide a succinct answer. 0.96. What is the difference between the highest and the second highest General Parity Index (GPI) of High income: OECD?
Your answer should be very brief. 0. What is the difference between the highest and the second highest General Parity Index (GPI) of Belarus?
Your response must be concise. 0. What is the difference between the highest and the second highest General Parity Index (GPI) of Mozambique?
Provide a short and direct response. 0.03. What is the difference between the highest and the second highest General Parity Index (GPI) in Uruguay?
Your answer should be compact. 0.02. What is the difference between the highest and the lowest General Parity Index (GPI) of High income: OECD?
Offer a terse response. 0.15. What is the difference between the highest and the lowest General Parity Index (GPI) of Belarus?
Offer a very short reply. 0.11. What is the difference between the highest and the lowest General Parity Index (GPI) in Mozambique?
Provide a short and direct response. 0.43. What is the difference between the highest and the lowest General Parity Index (GPI) in Uruguay?
Offer a terse response. 0.06. 